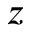<formula> <loc_0><loc_0><loc_500><loc_500>z</formula> 